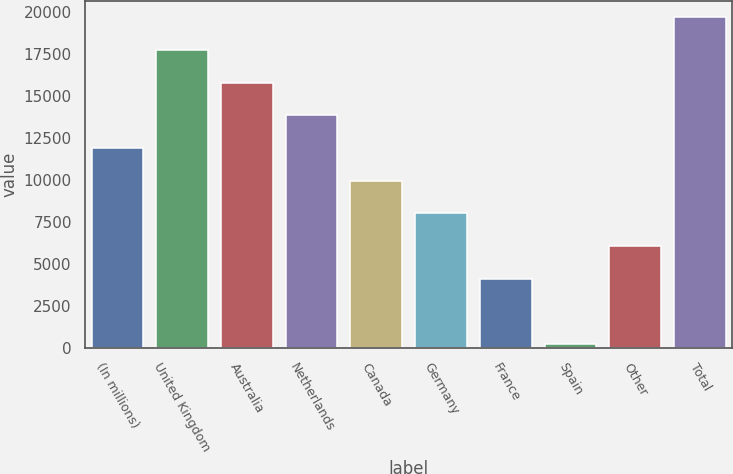Convert chart to OTSL. <chart><loc_0><loc_0><loc_500><loc_500><bar_chart><fcel>(In millions)<fcel>United Kingdom<fcel>Australia<fcel>Netherlands<fcel>Canada<fcel>Germany<fcel>France<fcel>Spain<fcel>Other<fcel>Total<nl><fcel>11895.6<fcel>17729.4<fcel>15784.8<fcel>13840.2<fcel>9951<fcel>8006.4<fcel>4117.2<fcel>228<fcel>6061.8<fcel>19674<nl></chart> 